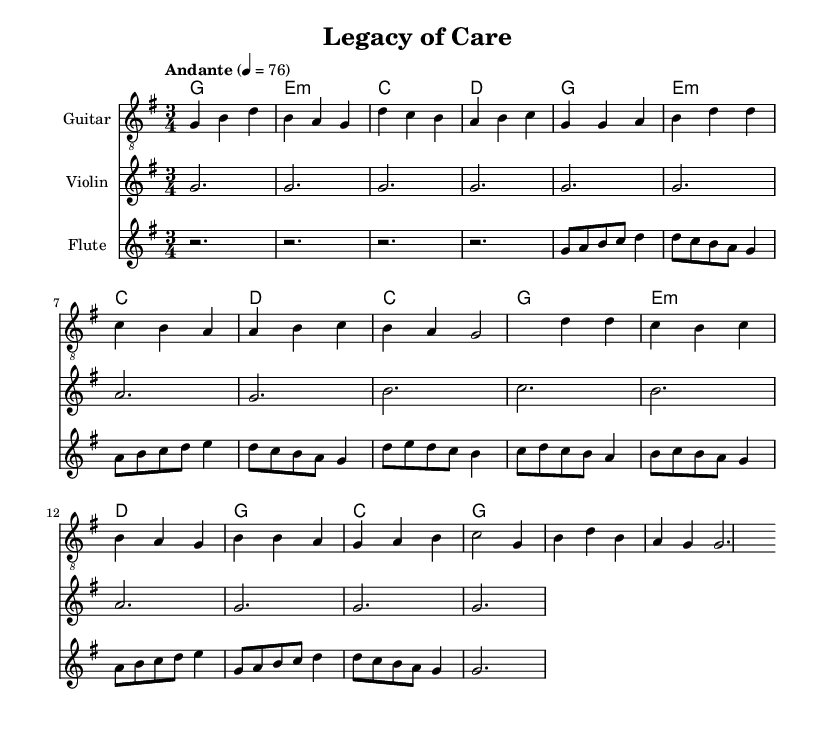What is the key signature of this music? The key signature is G major, which has one sharp (F#). This can be identified by looking at the key signature symbol at the beginning of the staff.
Answer: G major What is the time signature of the piece? The time signature is 3/4, which indicates three beats per measure and a quarter note receives one beat. This is found at the beginning of the music right after the key signature.
Answer: 3/4 What is the tempo marking in this piece? The tempo marking is "Andante," which suggests a moderate pace. The tempo indication can typically be found written above the staff, along with a metronome marking.
Answer: Andante How many measures are in the chorus section? The chorus section contains four measures, as indicated by counting the divisions in the measures labeled "Chorus." Each line in the notation represents a set of measures dedicated specifically to that part.
Answer: 4 What is the instrument used for the melody in this piece? The melody is primarily carried by the flute, as indicated by the staff labeling. Each instrument's staff has an instrument name above it, showing its role in the piece.
Answer: Flute Which chord is played at the start of the verse? The chord played at the start of the verse is G major, which can be identified in the chord names section corresponding to the respective measure in the musical staff.
Answer: G What does the outro section primarily repeat from earlier in the music? The outro primarily repeats the intro section, as the musical notation for both sections matches. By comparing the measures at the beginning and end, it is evident they share similar melodic lines.
Answer: Intro 